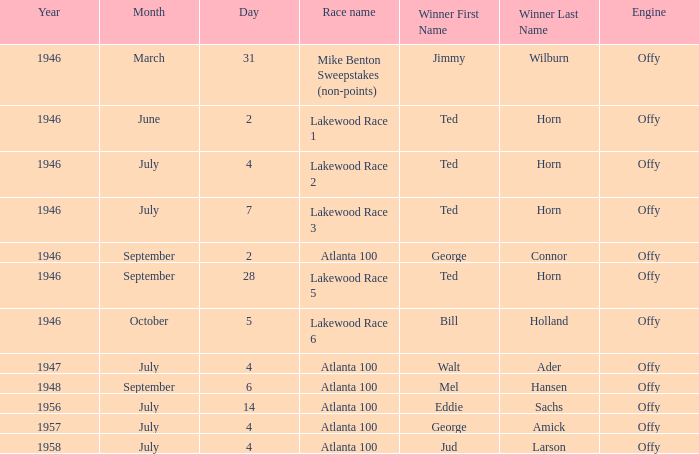Who won on September 6? Mel Hansen. 